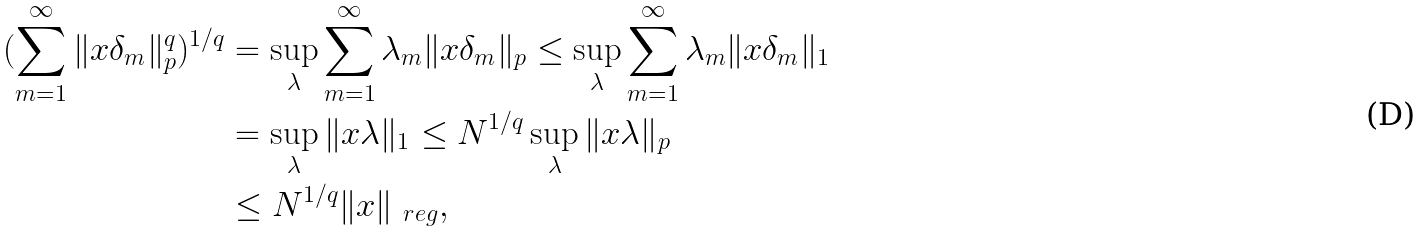Convert formula to latex. <formula><loc_0><loc_0><loc_500><loc_500>( \sum _ { m = 1 } ^ { \infty } \| x \delta _ { m } \| _ { p } ^ { q } ) ^ { 1 / q } & = \sup _ { \lambda } \sum _ { m = 1 } ^ { \infty } \lambda _ { m } \| x \delta _ { m } \| _ { p } \leq \sup _ { \lambda } \sum _ { m = 1 } ^ { \infty } \lambda _ { m } \| x \delta _ { m } \| _ { 1 } \\ & = \sup _ { \lambda } \| x \lambda \| _ { 1 } \leq N ^ { 1 / q } \sup _ { \lambda } \| x \lambda \| _ { p } \\ & \leq N ^ { 1 / q } \| x \| _ { \ r e g } ,</formula> 